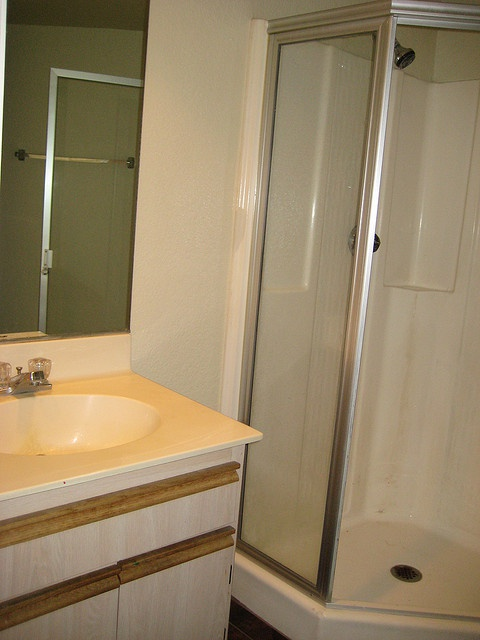Describe the objects in this image and their specific colors. I can see a sink in lightgray and tan tones in this image. 